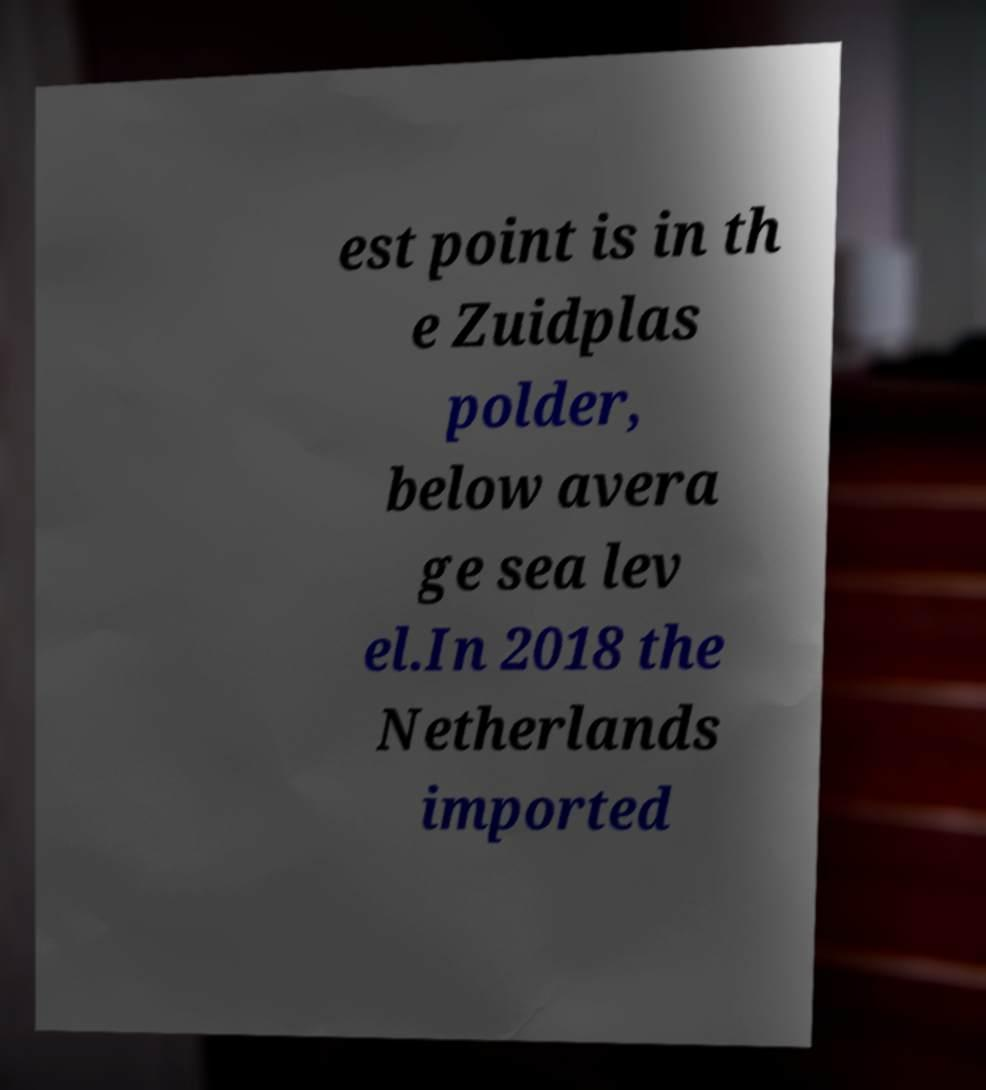There's text embedded in this image that I need extracted. Can you transcribe it verbatim? est point is in th e Zuidplas polder, below avera ge sea lev el.In 2018 the Netherlands imported 